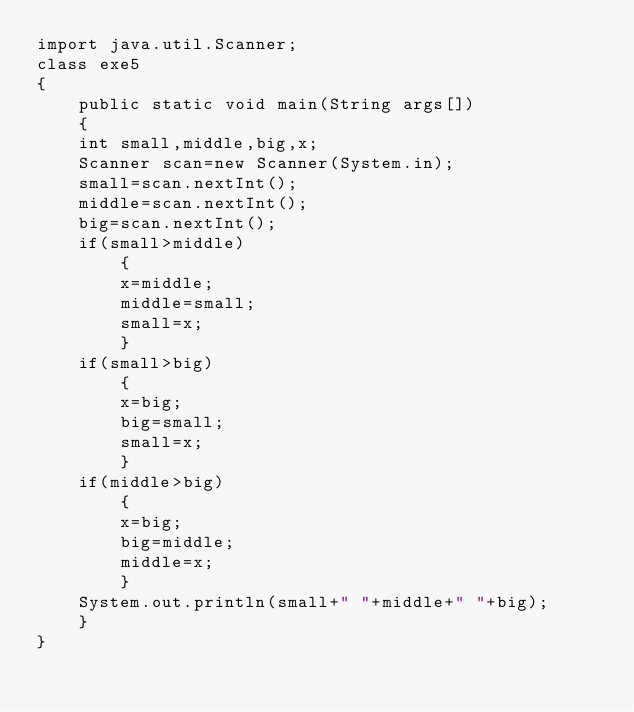Convert code to text. <code><loc_0><loc_0><loc_500><loc_500><_Java_>import java.util.Scanner;
class exe5
{
    public static void main(String args[])
    {
	int small,middle,big,x;
	Scanner scan=new Scanner(System.in);
	small=scan.nextInt();
	middle=scan.nextInt();
	big=scan.nextInt();
	if(small>middle)
	    {
		x=middle;
		middle=small;
		small=x;
	    }
	if(small>big)
	    {
		x=big;
		big=small;
		small=x;
	    }
	if(middle>big)
	    {
		x=big;
		big=middle;
		middle=x;
	    }
	System.out.println(small+" "+middle+" "+big);
    }
}</code> 